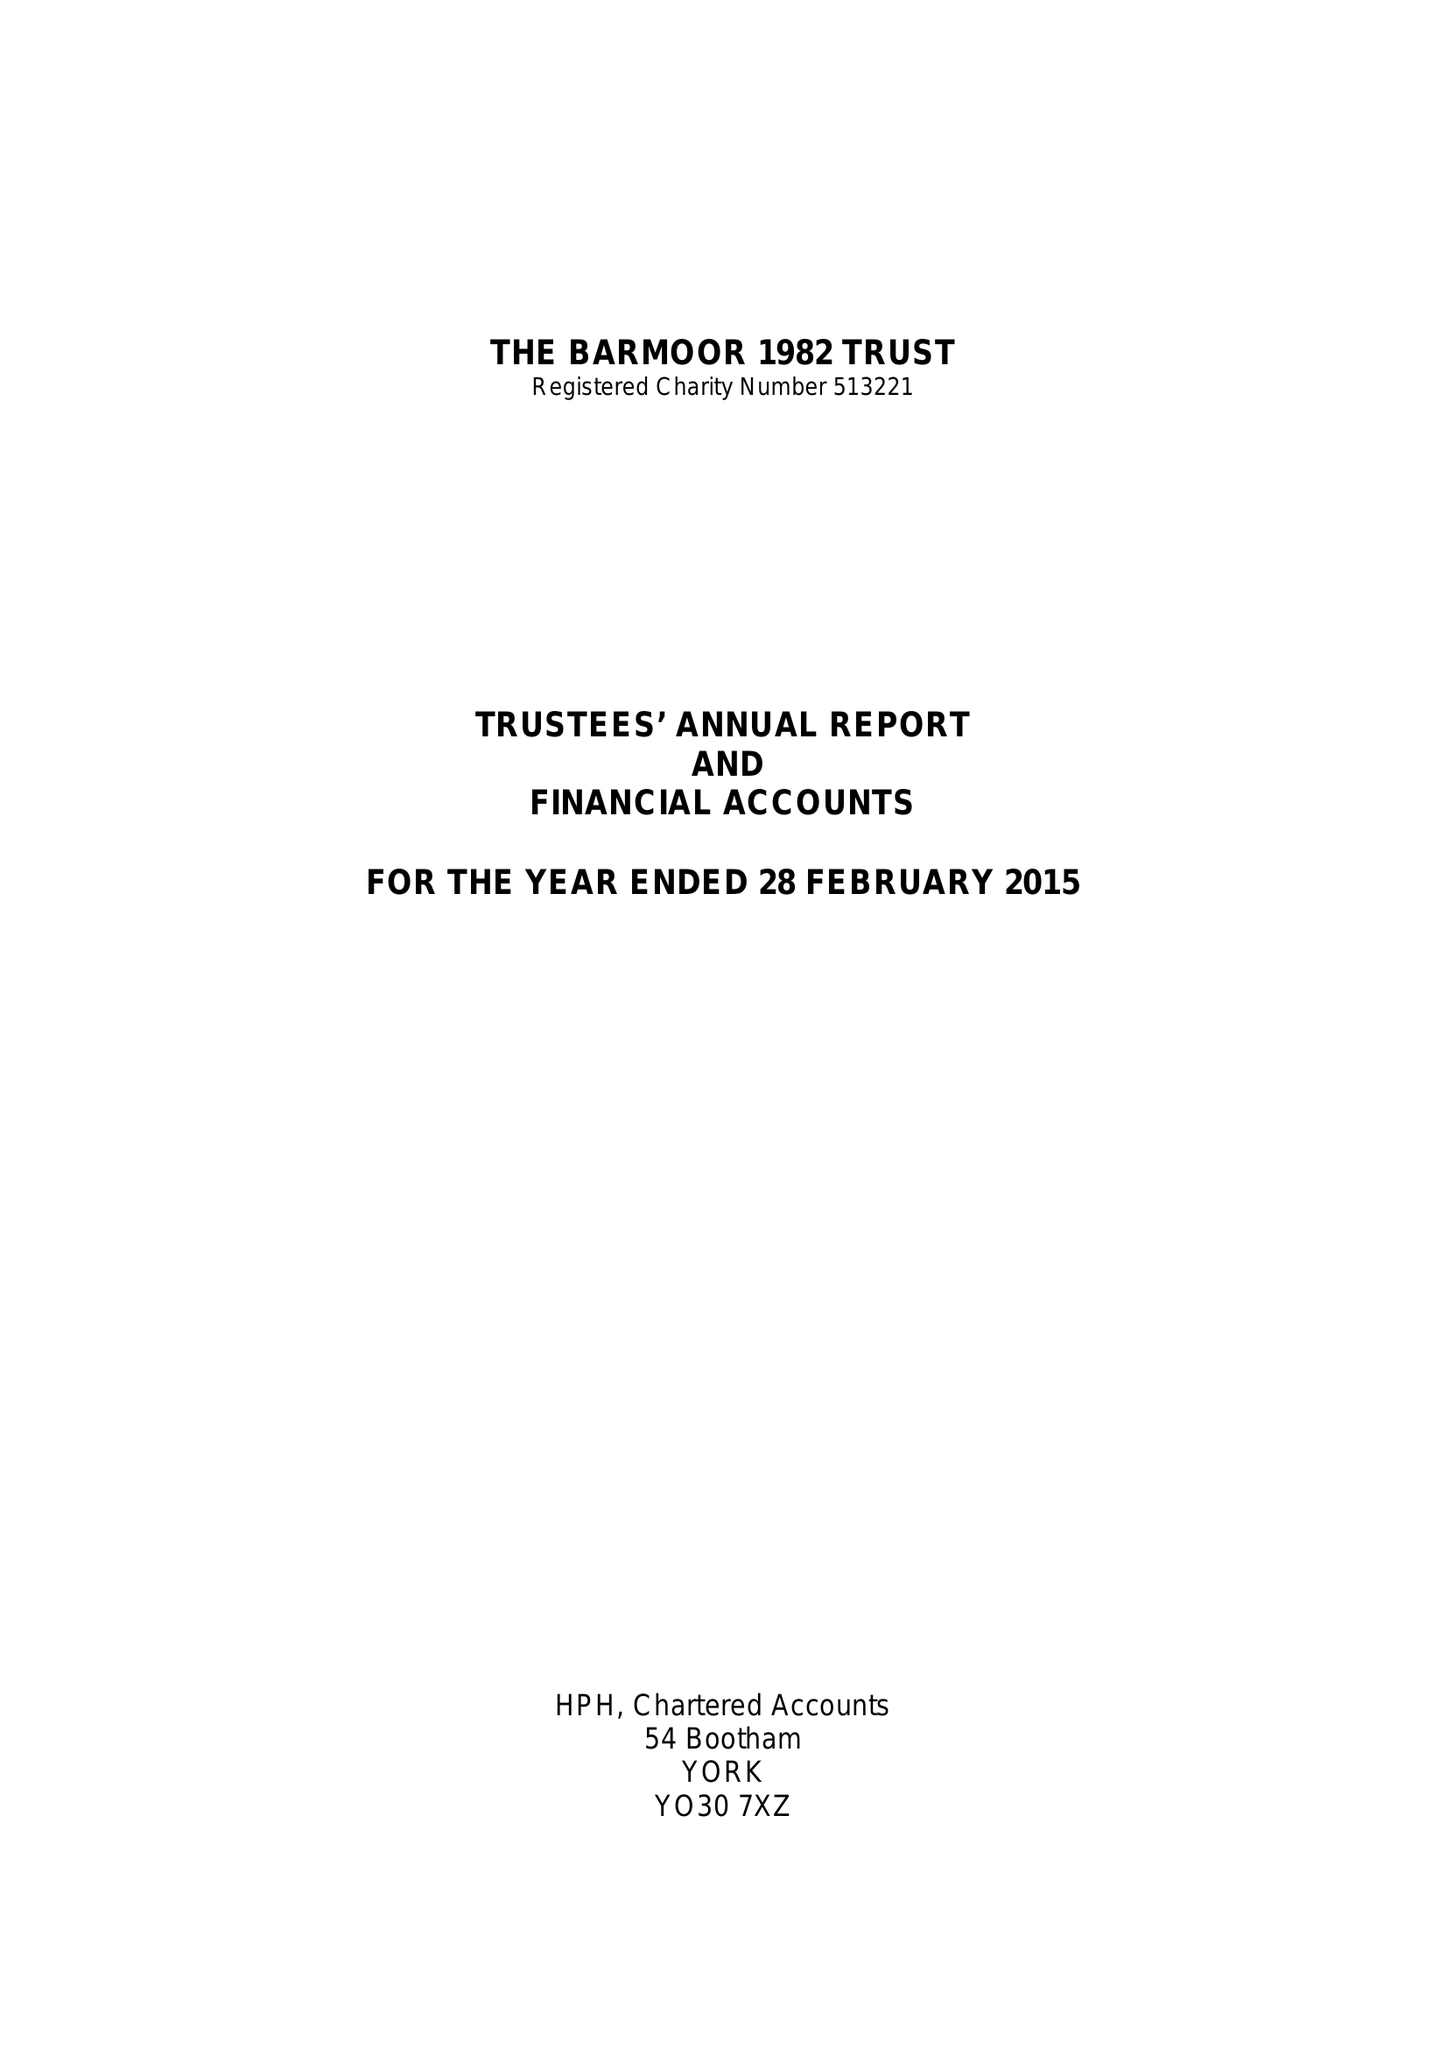What is the value for the address__street_line?
Answer the question using a single word or phrase. 15 DUNLOE AVENUE 